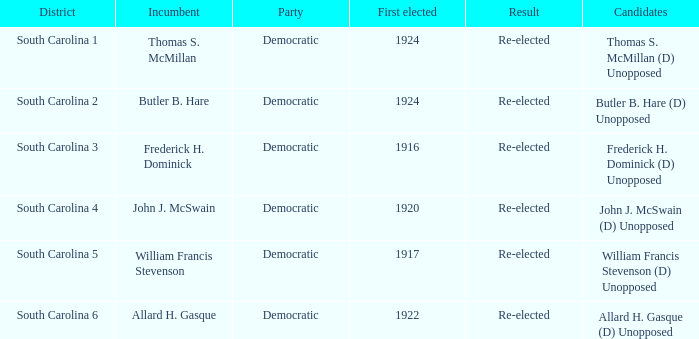Parse the full table. {'header': ['District', 'Incumbent', 'Party', 'First elected', 'Result', 'Candidates'], 'rows': [['South Carolina 1', 'Thomas S. McMillan', 'Democratic', '1924', 'Re-elected', 'Thomas S. McMillan (D) Unopposed'], ['South Carolina 2', 'Butler B. Hare', 'Democratic', '1924', 'Re-elected', 'Butler B. Hare (D) Unopposed'], ['South Carolina 3', 'Frederick H. Dominick', 'Democratic', '1916', 'Re-elected', 'Frederick H. Dominick (D) Unopposed'], ['South Carolina 4', 'John J. McSwain', 'Democratic', '1920', 'Re-elected', 'John J. McSwain (D) Unopposed'], ['South Carolina 5', 'William Francis Stevenson', 'Democratic', '1917', 'Re-elected', 'William Francis Stevenson (D) Unopposed'], ['South Carolina 6', 'Allard H. Gasque', 'Democratic', '1922', 'Re-elected', 'Allard H. Gasque (D) Unopposed']]} Who is the nominee for south carolina 1? Thomas S. McMillan (D) Unopposed. 